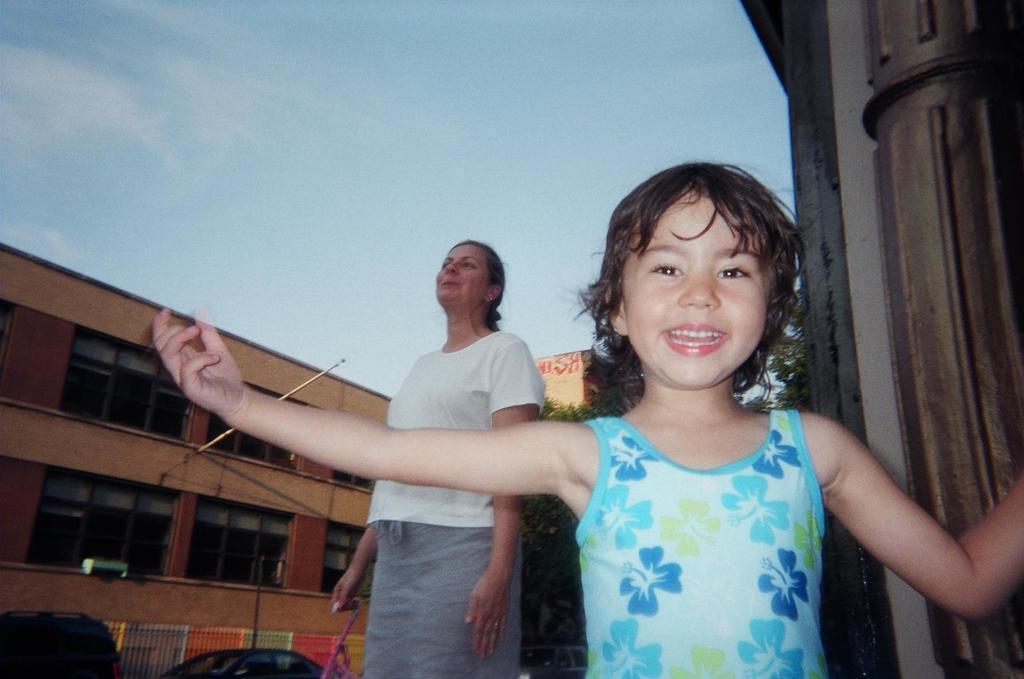How many people are standing in the image? There are two people standing in the image, a girl and a woman. What is the woman holding in her hand? The woman is holding a stick in her hand. What can be seen in the background of the image? There are cars parked on the road and a building visible in the background of the image. What type of bell can be heard ringing in the image? There is no bell present in the image, and therefore no sound can be heard. 